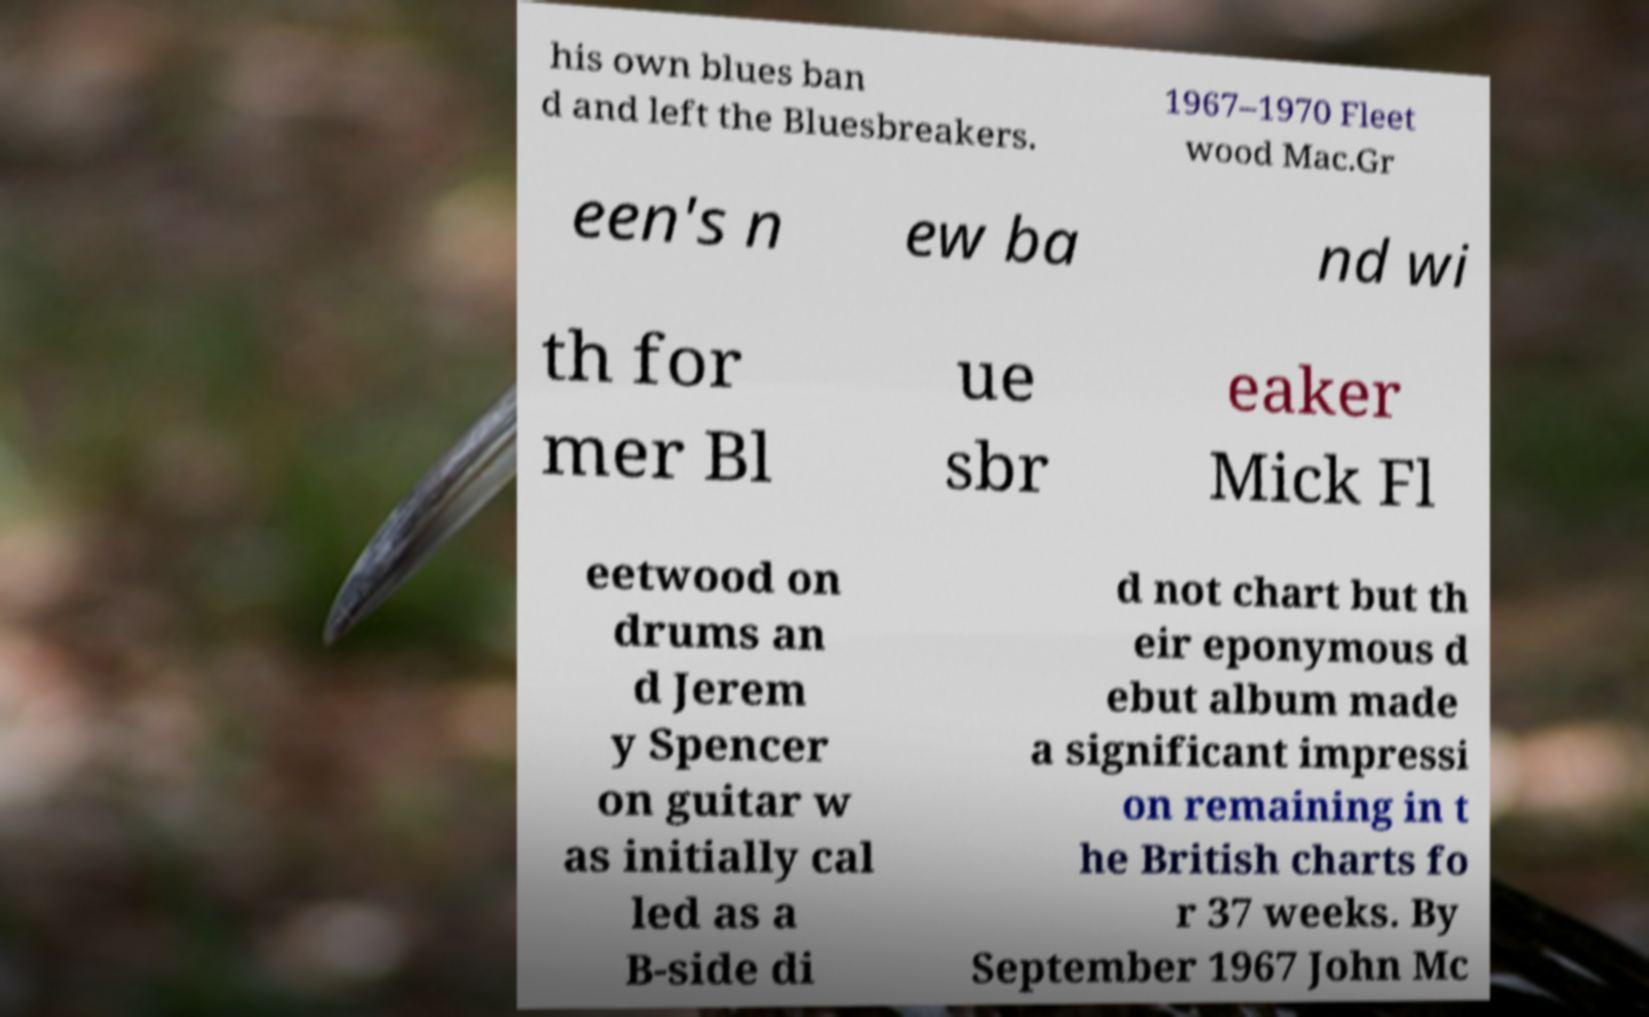Can you accurately transcribe the text from the provided image for me? his own blues ban d and left the Bluesbreakers. 1967–1970 Fleet wood Mac.Gr een's n ew ba nd wi th for mer Bl ue sbr eaker Mick Fl eetwood on drums an d Jerem y Spencer on guitar w as initially cal led as a B-side di d not chart but th eir eponymous d ebut album made a significant impressi on remaining in t he British charts fo r 37 weeks. By September 1967 John Mc 